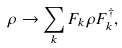<formula> <loc_0><loc_0><loc_500><loc_500>\rho \rightarrow \sum _ { k } F _ { k } \rho F _ { k } ^ { \dagger } ,</formula> 